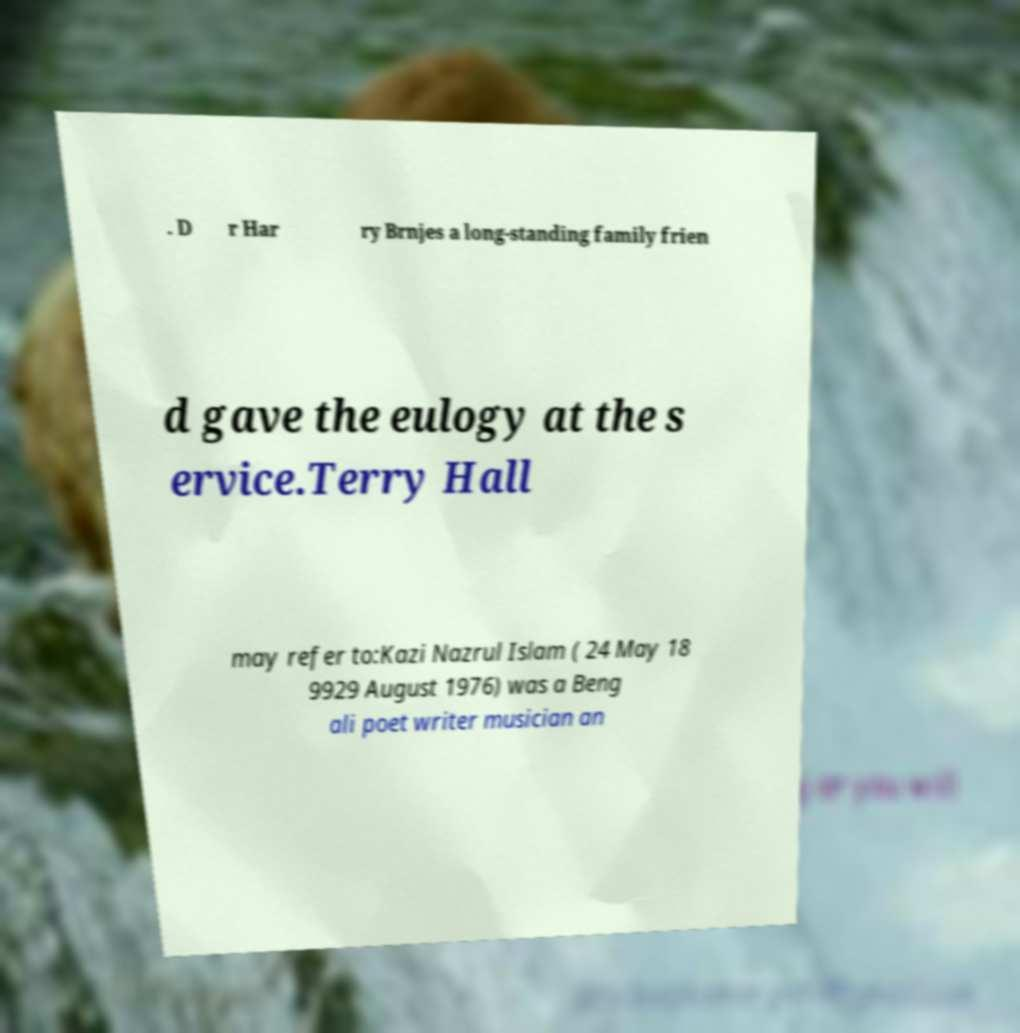I need the written content from this picture converted into text. Can you do that? . D r Har ry Brnjes a long-standing family frien d gave the eulogy at the s ervice.Terry Hall may refer to:Kazi Nazrul Islam ( 24 May 18 9929 August 1976) was a Beng ali poet writer musician an 